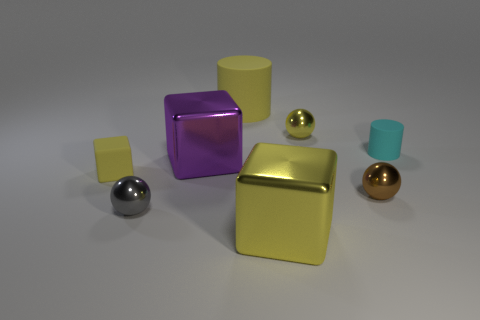What textures can you identify in this arrangement? The objects exhibit different textures. The spheres have a reflective metallic finish, while the cubes have what seems to be a matte, slightly textured surface. Do the objects seem randomly placed or intentionally arranged? The objects are likely intentionally arranged to display varying sizes, colors, and spacings, which provides a visually balanced composition. 